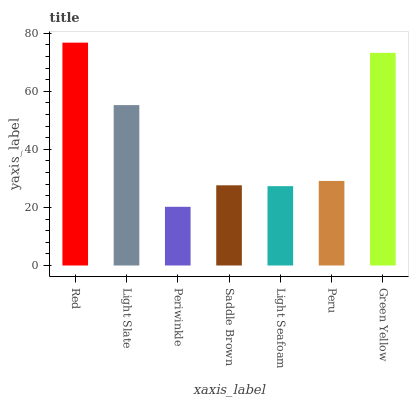Is Periwinkle the minimum?
Answer yes or no. Yes. Is Red the maximum?
Answer yes or no. Yes. Is Light Slate the minimum?
Answer yes or no. No. Is Light Slate the maximum?
Answer yes or no. No. Is Red greater than Light Slate?
Answer yes or no. Yes. Is Light Slate less than Red?
Answer yes or no. Yes. Is Light Slate greater than Red?
Answer yes or no. No. Is Red less than Light Slate?
Answer yes or no. No. Is Peru the high median?
Answer yes or no. Yes. Is Peru the low median?
Answer yes or no. Yes. Is Green Yellow the high median?
Answer yes or no. No. Is Saddle Brown the low median?
Answer yes or no. No. 